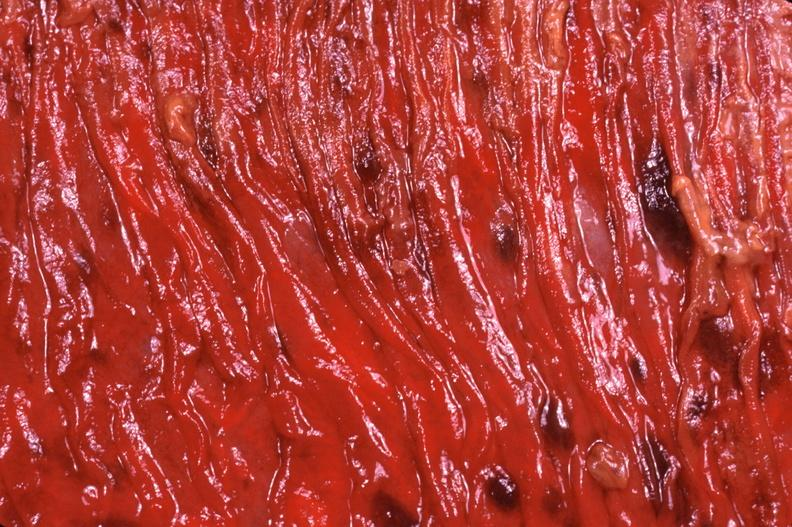what is present?
Answer the question using a single word or phrase. Gastrointestinal 